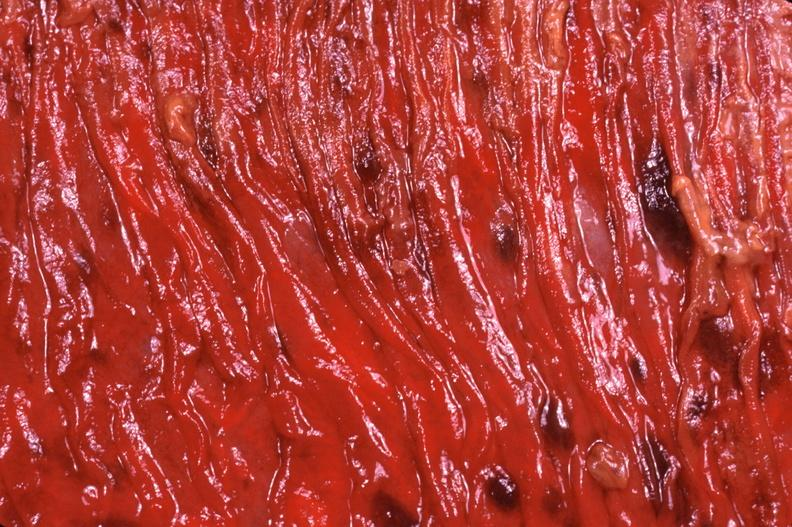what is present?
Answer the question using a single word or phrase. Gastrointestinal 